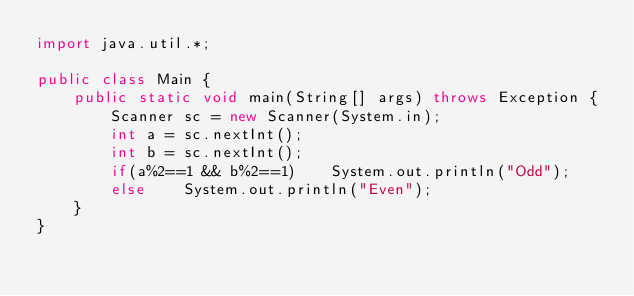Convert code to text. <code><loc_0><loc_0><loc_500><loc_500><_Java_>import java.util.*;

public class Main {
    public static void main(String[] args) throws Exception {
        Scanner sc = new Scanner(System.in);
        int a = sc.nextInt();
        int b = sc.nextInt();
        if(a%2==1 && b%2==1)    System.out.println("Odd");
        else    System.out.println("Even");
    }
}
</code> 